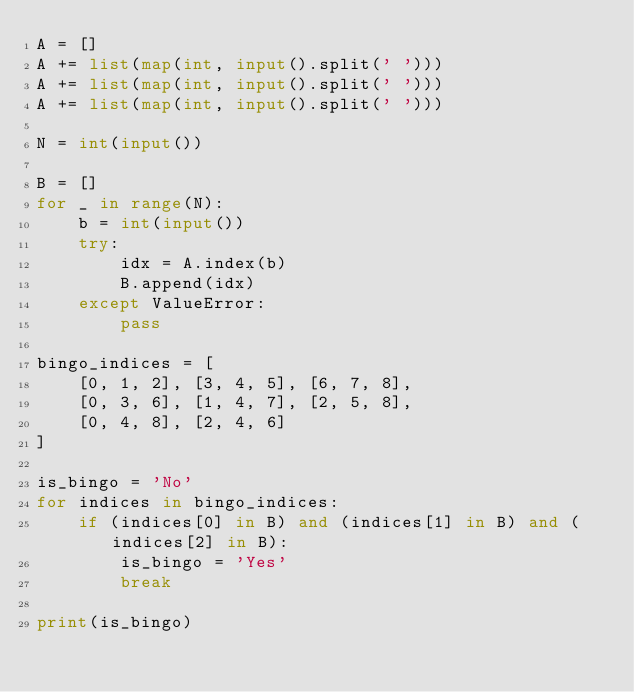<code> <loc_0><loc_0><loc_500><loc_500><_Python_>A = []
A += list(map(int, input().split(' ')))
A += list(map(int, input().split(' ')))
A += list(map(int, input().split(' ')))

N = int(input())

B = []
for _ in range(N):
    b = int(input())
    try:
        idx = A.index(b)
        B.append(idx)
    except ValueError:
        pass

bingo_indices = [
    [0, 1, 2], [3, 4, 5], [6, 7, 8],
    [0, 3, 6], [1, 4, 7], [2, 5, 8],
    [0, 4, 8], [2, 4, 6]
]

is_bingo = 'No'
for indices in bingo_indices:
    if (indices[0] in B) and (indices[1] in B) and (indices[2] in B):
        is_bingo = 'Yes'
        break

print(is_bingo)</code> 